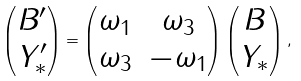Convert formula to latex. <formula><loc_0><loc_0><loc_500><loc_500>\begin{pmatrix} B ^ { \prime } \\ Y _ { * } ^ { \prime } \end{pmatrix} = \begin{pmatrix} \omega _ { 1 } & \omega _ { 3 } \\ \omega _ { 3 } & - \omega _ { 1 } \end{pmatrix} \begin{pmatrix} B \\ Y _ { * } \end{pmatrix} ,</formula> 